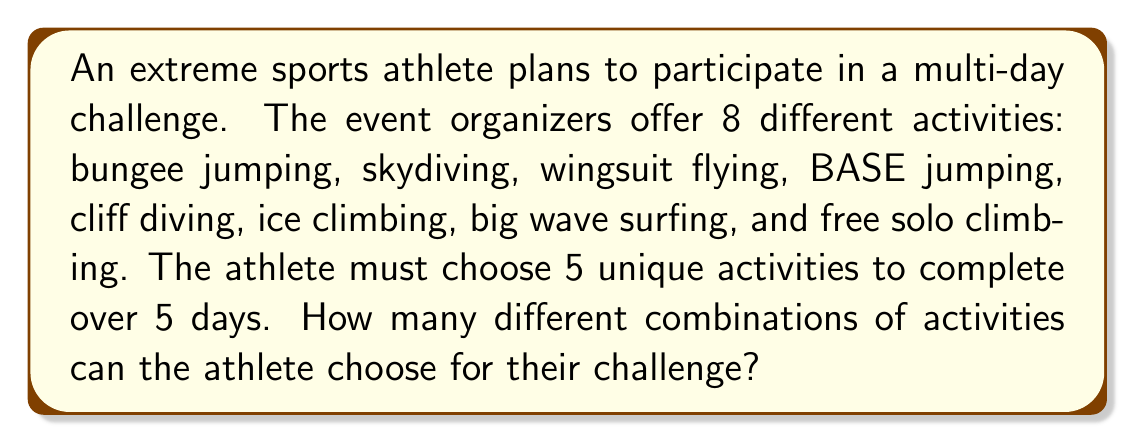Give your solution to this math problem. To solve this problem, we need to use the combination formula, as the order of activities doesn't matter (it's not a permutation) and we can't repeat activities.

1. We have 8 total activities to choose from (n = 8).
2. We need to select 5 activities (r = 5).
3. The combination formula is:

   $$C(n,r) = \frac{n!}{r!(n-r)!}$$

4. Plugging in our values:

   $$C(8,5) = \frac{8!}{5!(8-5)!} = \frac{8!}{5!3!}$$

5. Expand this:
   
   $$\frac{8 \cdot 7 \cdot 6 \cdot 5!}{5! \cdot 3 \cdot 2 \cdot 1}$$

6. The 5! cancels out in the numerator and denominator:

   $$\frac{8 \cdot 7 \cdot 6}{3 \cdot 2 \cdot 1} = \frac{336}{6}$$

7. Simplify:

   $$336 \div 6 = 56$$

Therefore, there are 56 different combinations of activities the athlete can choose for their 5-day challenge.
Answer: 56 